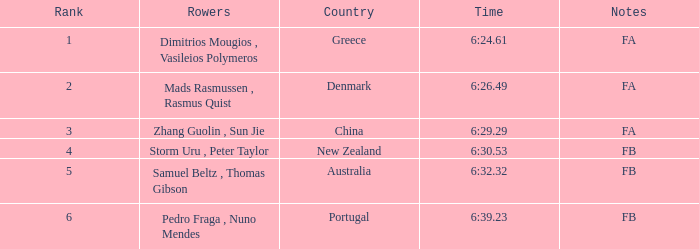61? Dimitrios Mougios , Vasileios Polymeros. 